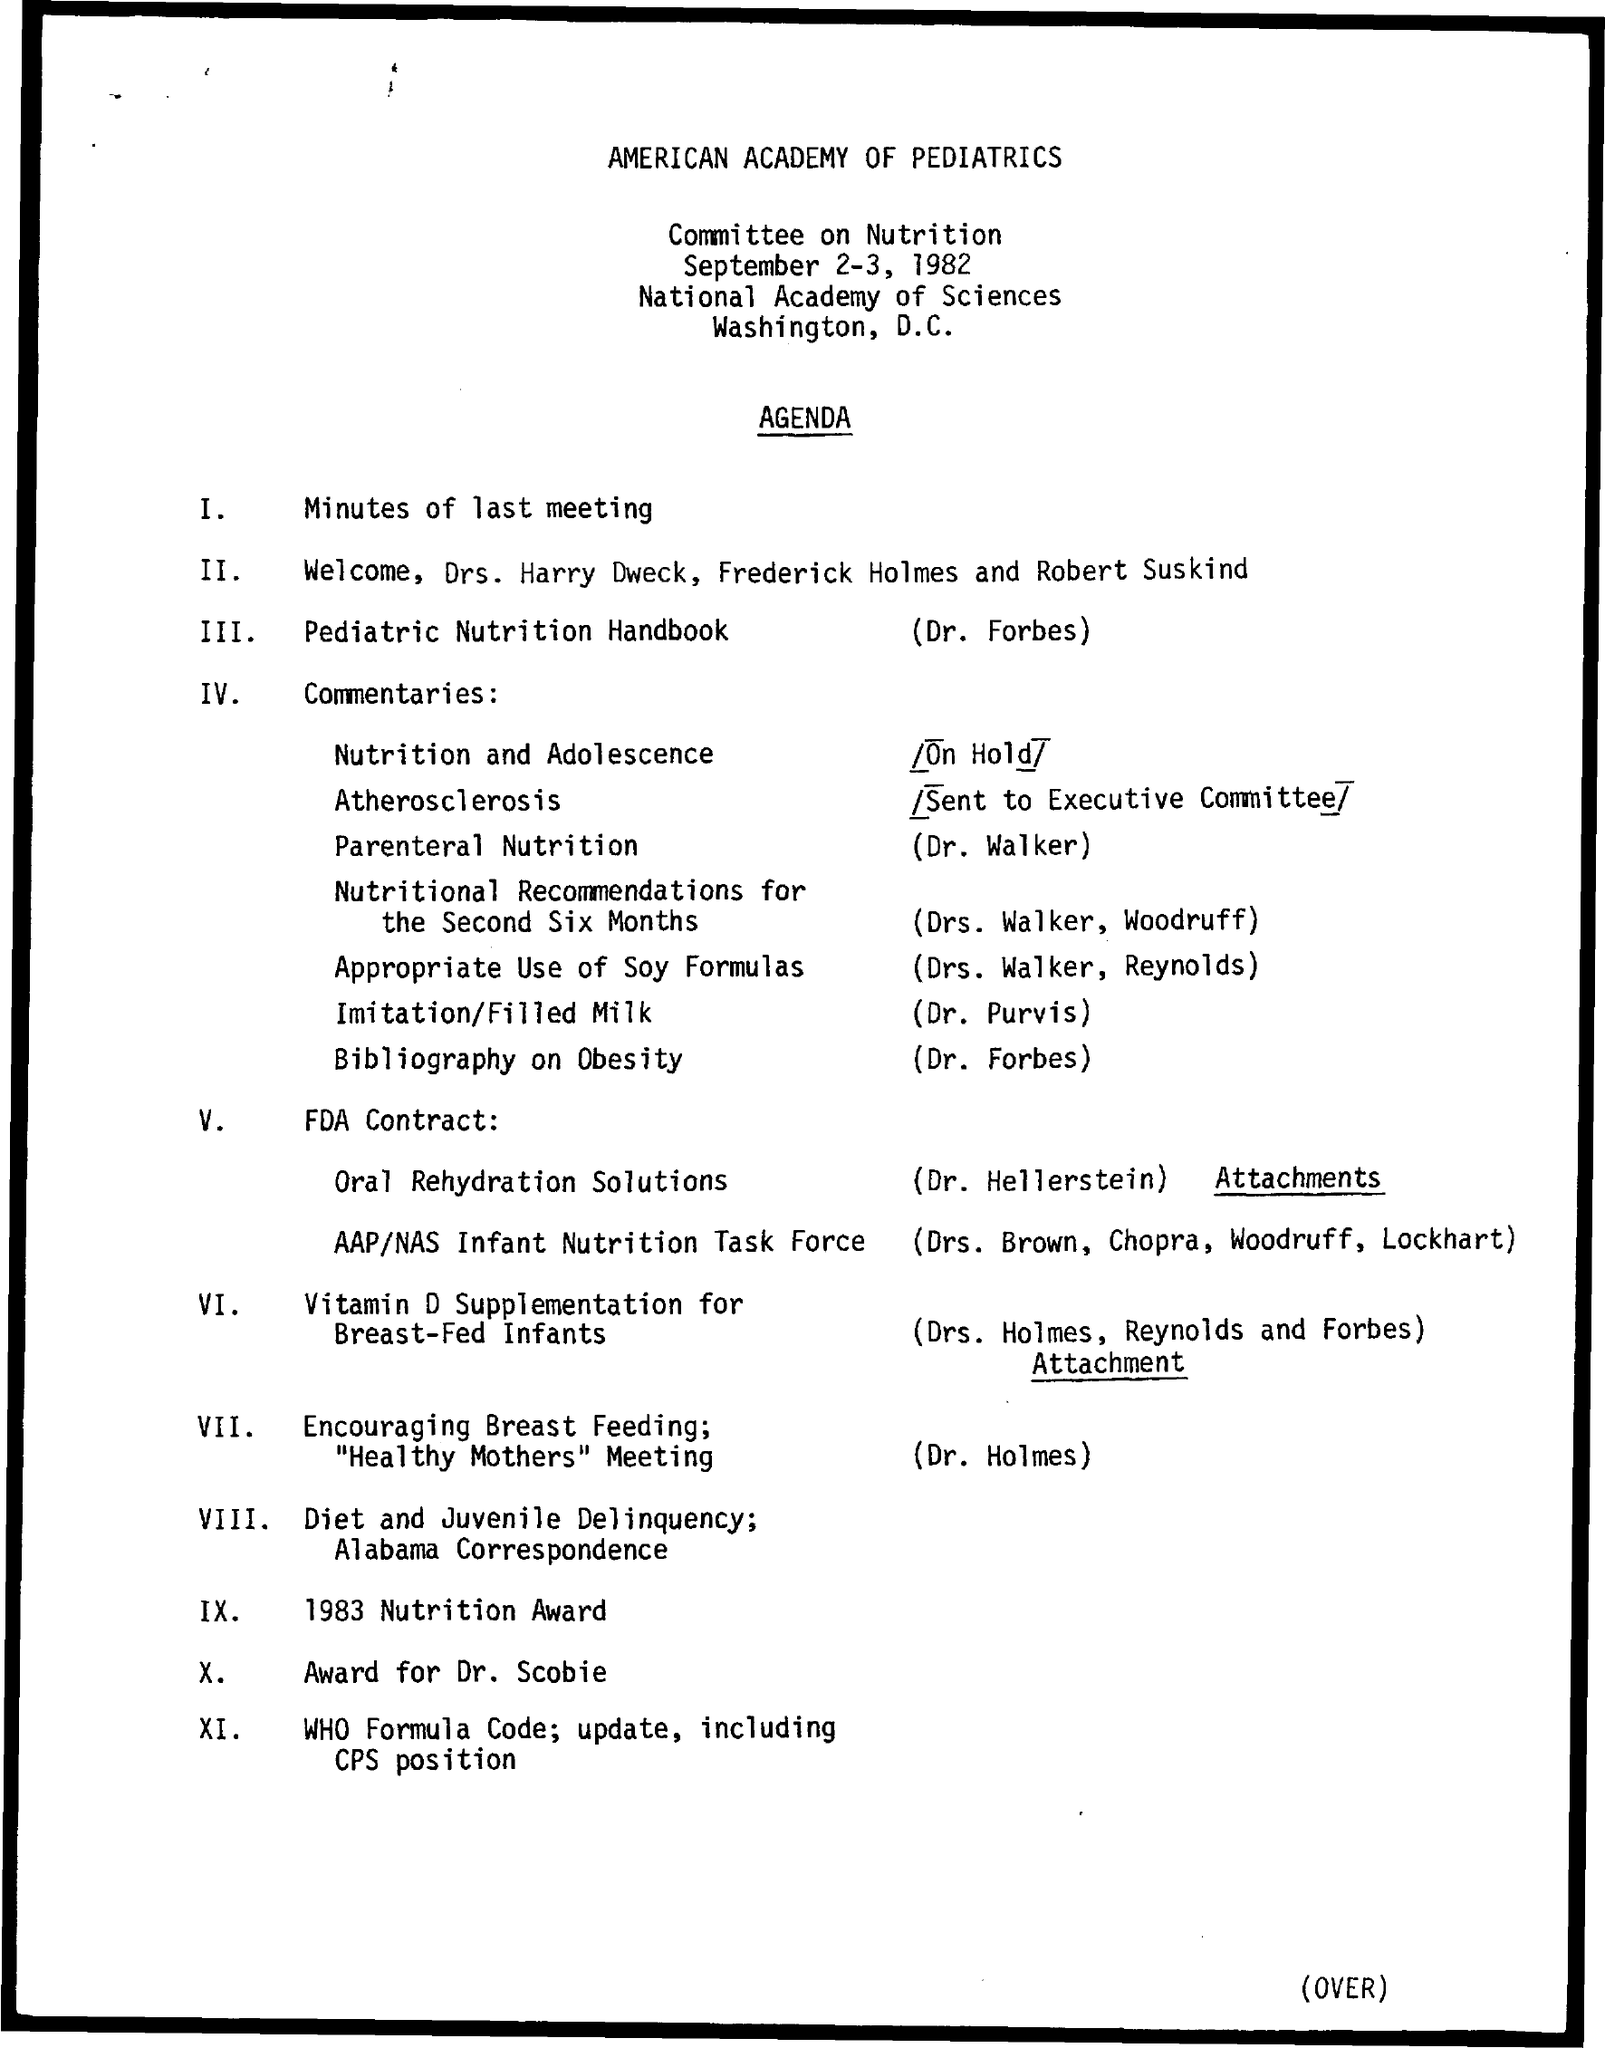Specify some key components in this picture. At the previous meeting, the agenda item numbered I was discussed, and the minutes of the meeting were reviewed. The document's title is "What is the title of the document? American Academy of Pediatrics.. The agenda item is IX, and it concerns the 1983 Nutrition Award. The agenda item is III, which pertains to pediatric nutrition as outlined in the Pediatric Nutrition Handbook. The agenda item is X, and Dr. Scobie will be receiving an award. 